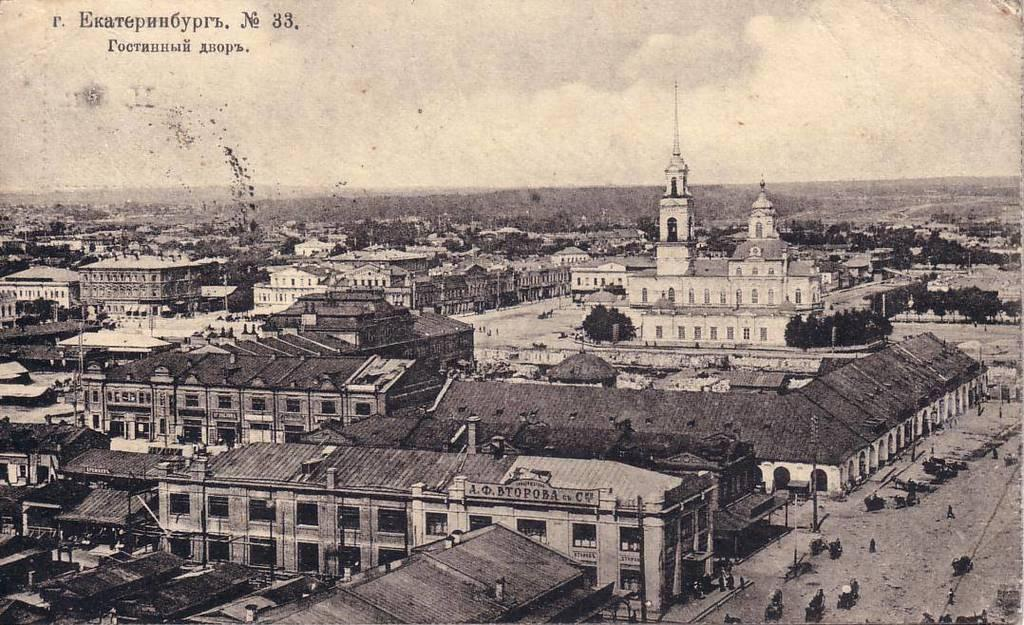What types of objects are present in the image? There are vehicles, persons walking on the road, buildings, and trees in the image. What can be seen in the background of the image? The buildings and trees are visible in the background of the image. What is the condition of the sky in the image? The sky is visible in the image. What is the color scheme of the image? The image is in black and white. Can you tell me how many cherries are hanging from the trees in the image? There are no cherries present in the image; it features trees without any fruit. What type of wall is visible in the image? There is no wall visible in the image; it features buildings, trees, vehicles, and persons walking on the road. 